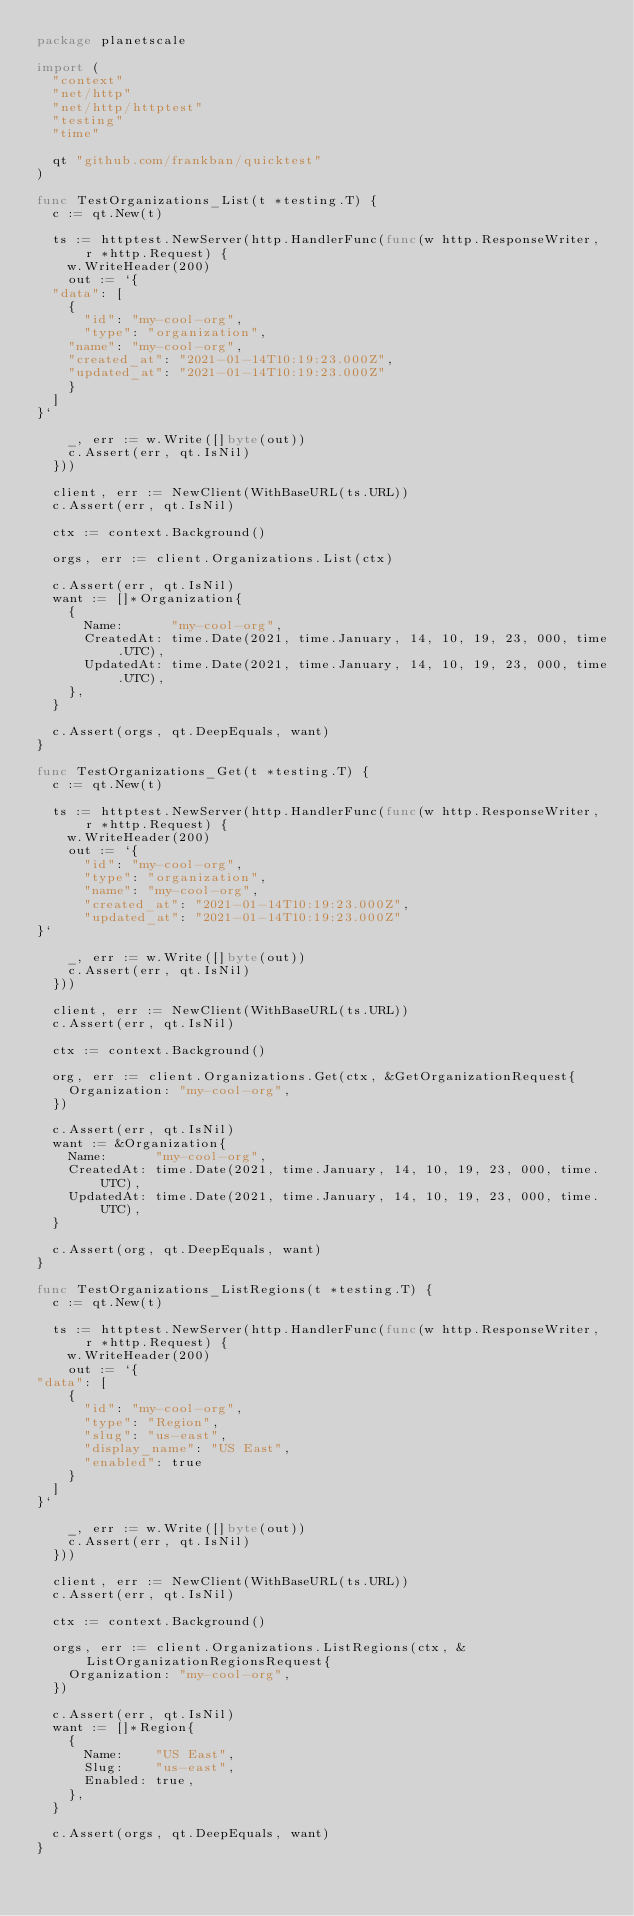Convert code to text. <code><loc_0><loc_0><loc_500><loc_500><_Go_>package planetscale

import (
	"context"
	"net/http"
	"net/http/httptest"
	"testing"
	"time"

	qt "github.com/frankban/quicktest"
)

func TestOrganizations_List(t *testing.T) {
	c := qt.New(t)

	ts := httptest.NewServer(http.HandlerFunc(func(w http.ResponseWriter, r *http.Request) {
		w.WriteHeader(200)
		out := `{
  "data": [
    {
      "id": "my-cool-org",
      "type": "organization",
	  "name": "my-cool-org",
	  "created_at": "2021-01-14T10:19:23.000Z",
	  "updated_at": "2021-01-14T10:19:23.000Z"
    }
  ]
}`

		_, err := w.Write([]byte(out))
		c.Assert(err, qt.IsNil)
	}))

	client, err := NewClient(WithBaseURL(ts.URL))
	c.Assert(err, qt.IsNil)

	ctx := context.Background()

	orgs, err := client.Organizations.List(ctx)

	c.Assert(err, qt.IsNil)
	want := []*Organization{
		{
			Name:      "my-cool-org",
			CreatedAt: time.Date(2021, time.January, 14, 10, 19, 23, 000, time.UTC),
			UpdatedAt: time.Date(2021, time.January, 14, 10, 19, 23, 000, time.UTC),
		},
	}

	c.Assert(orgs, qt.DeepEquals, want)
}

func TestOrganizations_Get(t *testing.T) {
	c := qt.New(t)

	ts := httptest.NewServer(http.HandlerFunc(func(w http.ResponseWriter, r *http.Request) {
		w.WriteHeader(200)
		out := `{
      "id": "my-cool-org",
      "type": "organization",
      "name": "my-cool-org",
      "created_at": "2021-01-14T10:19:23.000Z",
      "updated_at": "2021-01-14T10:19:23.000Z"
}`

		_, err := w.Write([]byte(out))
		c.Assert(err, qt.IsNil)
	}))

	client, err := NewClient(WithBaseURL(ts.URL))
	c.Assert(err, qt.IsNil)

	ctx := context.Background()

	org, err := client.Organizations.Get(ctx, &GetOrganizationRequest{
		Organization: "my-cool-org",
	})

	c.Assert(err, qt.IsNil)
	want := &Organization{
		Name:      "my-cool-org",
		CreatedAt: time.Date(2021, time.January, 14, 10, 19, 23, 000, time.UTC),
		UpdatedAt: time.Date(2021, time.January, 14, 10, 19, 23, 000, time.UTC),
	}

	c.Assert(org, qt.DeepEquals, want)
}

func TestOrganizations_ListRegions(t *testing.T) {
	c := qt.New(t)

	ts := httptest.NewServer(http.HandlerFunc(func(w http.ResponseWriter, r *http.Request) {
		w.WriteHeader(200)
		out := `{
"data": [
		{
			"id": "my-cool-org",
			"type": "Region",
			"slug": "us-east",
			"display_name": "US East",
			"enabled": true
		}
	]
}`

		_, err := w.Write([]byte(out))
		c.Assert(err, qt.IsNil)
	}))

	client, err := NewClient(WithBaseURL(ts.URL))
	c.Assert(err, qt.IsNil)

	ctx := context.Background()

	orgs, err := client.Organizations.ListRegions(ctx, &ListOrganizationRegionsRequest{
		Organization: "my-cool-org",
	})

	c.Assert(err, qt.IsNil)
	want := []*Region{
		{
			Name:    "US East",
			Slug:    "us-east",
			Enabled: true,
		},
	}

	c.Assert(orgs, qt.DeepEquals, want)
}
</code> 